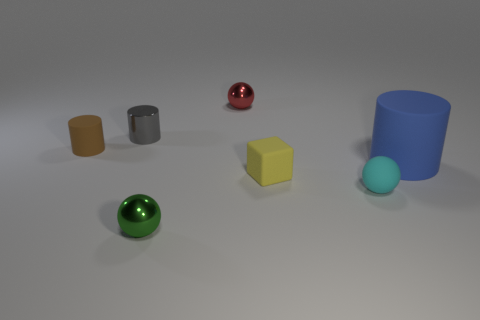Is there anything else that has the same size as the blue matte cylinder?
Offer a very short reply. No. There is a yellow thing that is the same size as the green shiny ball; what shape is it?
Give a very brief answer. Cube. Is there a tiny gray object of the same shape as the tiny brown thing?
Provide a short and direct response. Yes. Is the shape of the metallic object that is in front of the small metal cylinder the same as the object behind the small gray shiny object?
Your answer should be compact. Yes. What is the material of the yellow cube that is the same size as the gray cylinder?
Provide a short and direct response. Rubber. What number of other objects are there of the same material as the gray object?
Your response must be concise. 2. What shape is the object that is right of the matte thing in front of the tiny yellow cube?
Provide a short and direct response. Cylinder. How many objects are cubes or cylinders on the left side of the large blue rubber thing?
Give a very brief answer. 3. What number of blue objects are tiny rubber things or cylinders?
Provide a short and direct response. 1. There is a matte object that is on the left side of the tiny shiny ball that is to the left of the tiny red thing; is there a metal sphere on the left side of it?
Offer a terse response. No. 